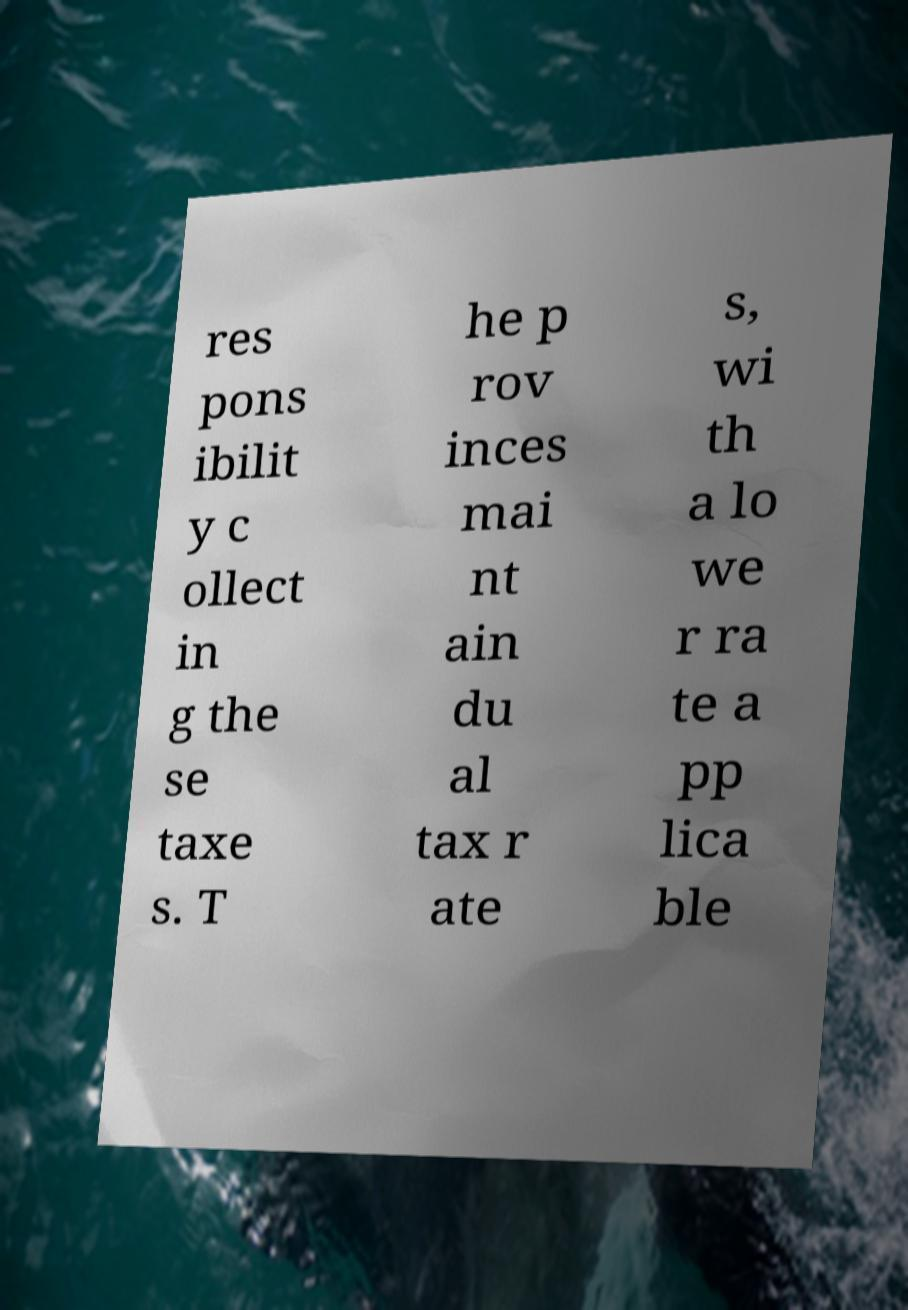Could you assist in decoding the text presented in this image and type it out clearly? res pons ibilit y c ollect in g the se taxe s. T he p rov inces mai nt ain du al tax r ate s, wi th a lo we r ra te a pp lica ble 